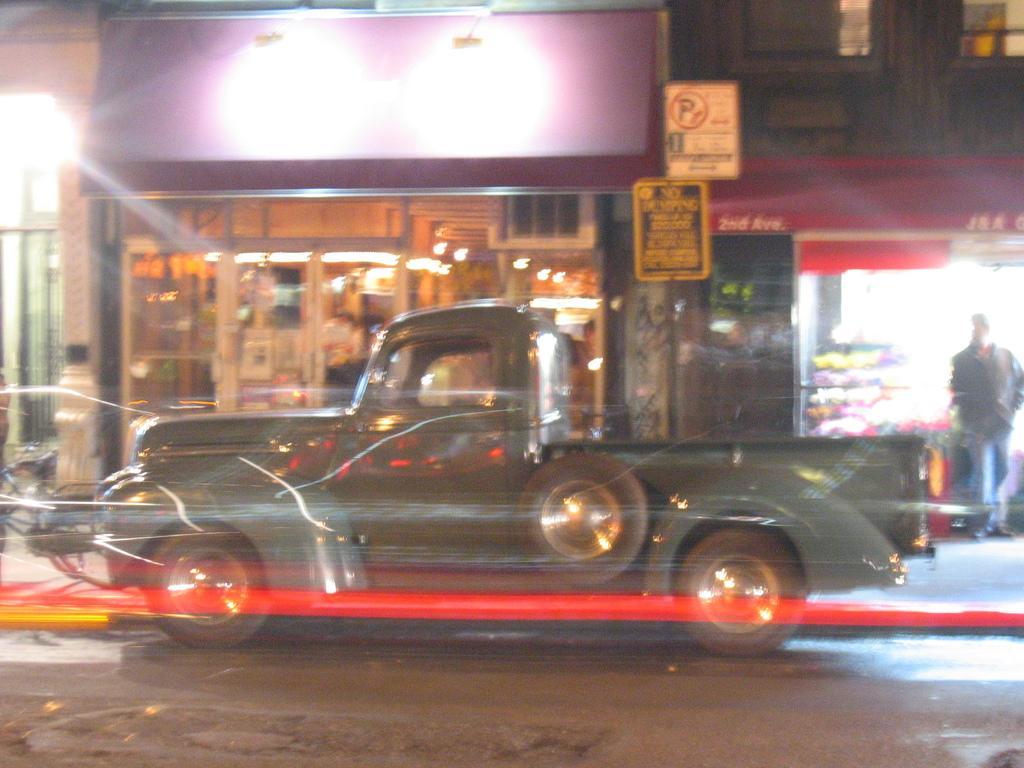How would you summarize this image in a sentence or two? In this image we can see a vehicle, name boards, lights, person, buildings and other objects. At the bottom of the image there is the road. 